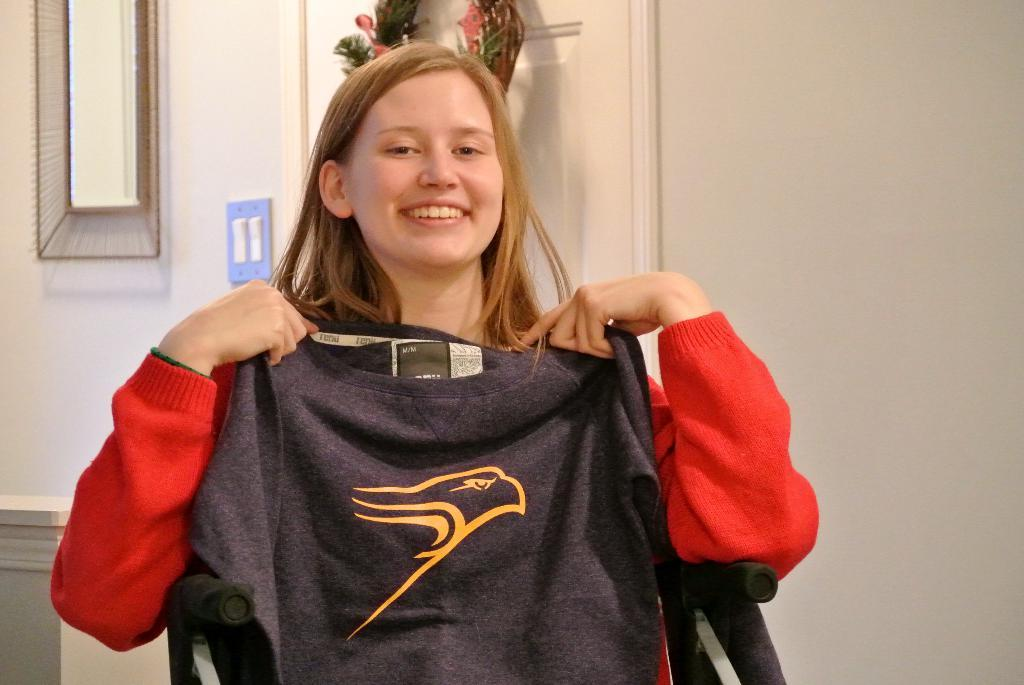Who is present in the image? There is a person in the image. Where is the person located? The person is in a room. What is the person's expression in the image? The person is smiling. What is the person holding in the image? The person is holding a t-shirt. What can be seen on the walls in the image? There is a wall visible in the image. Can you hear the person whistling in the image? There is no indication of whistling in the image, as it only shows a person holding a t-shirt and smiling in a room. 